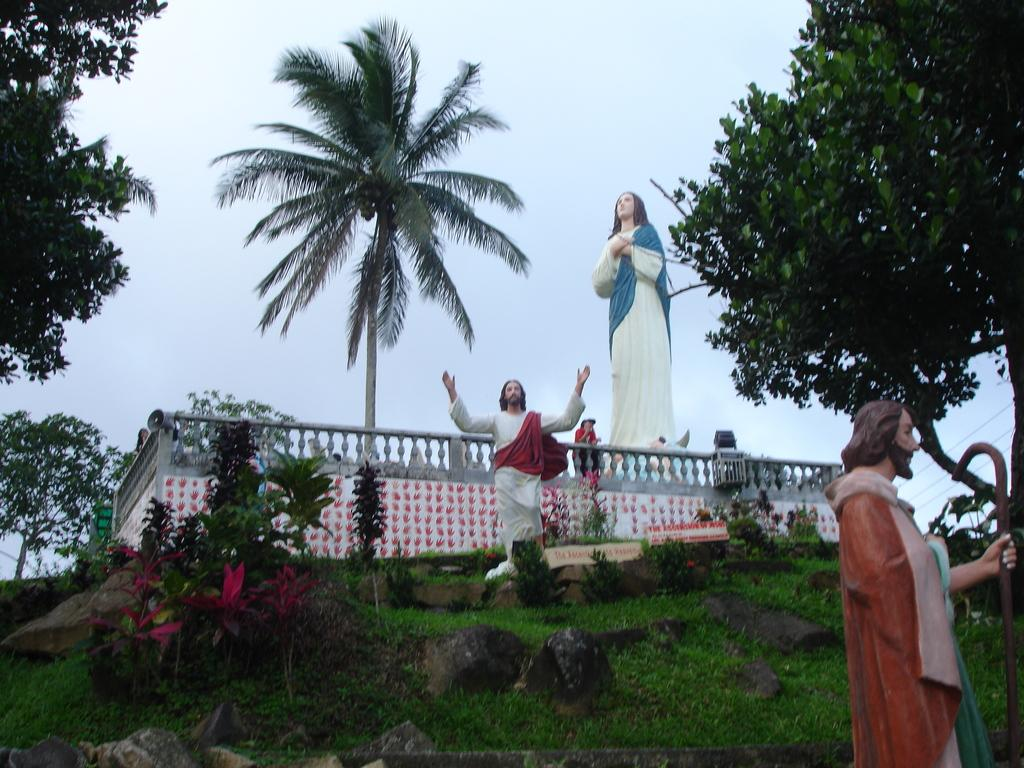What type of objects are depicted as sculptures in the image? There are sculptures of people in the image. What type of vegetation can be seen in the image? There is grass, plants, and trees in the image. What is visible in the background of the image? The sky is visible in the background of the image. What type of power source is used to keep the bubble floating in the image? There is no bubble present in the image, so it is not possible to determine what type of power source might be used to keep it floating. 